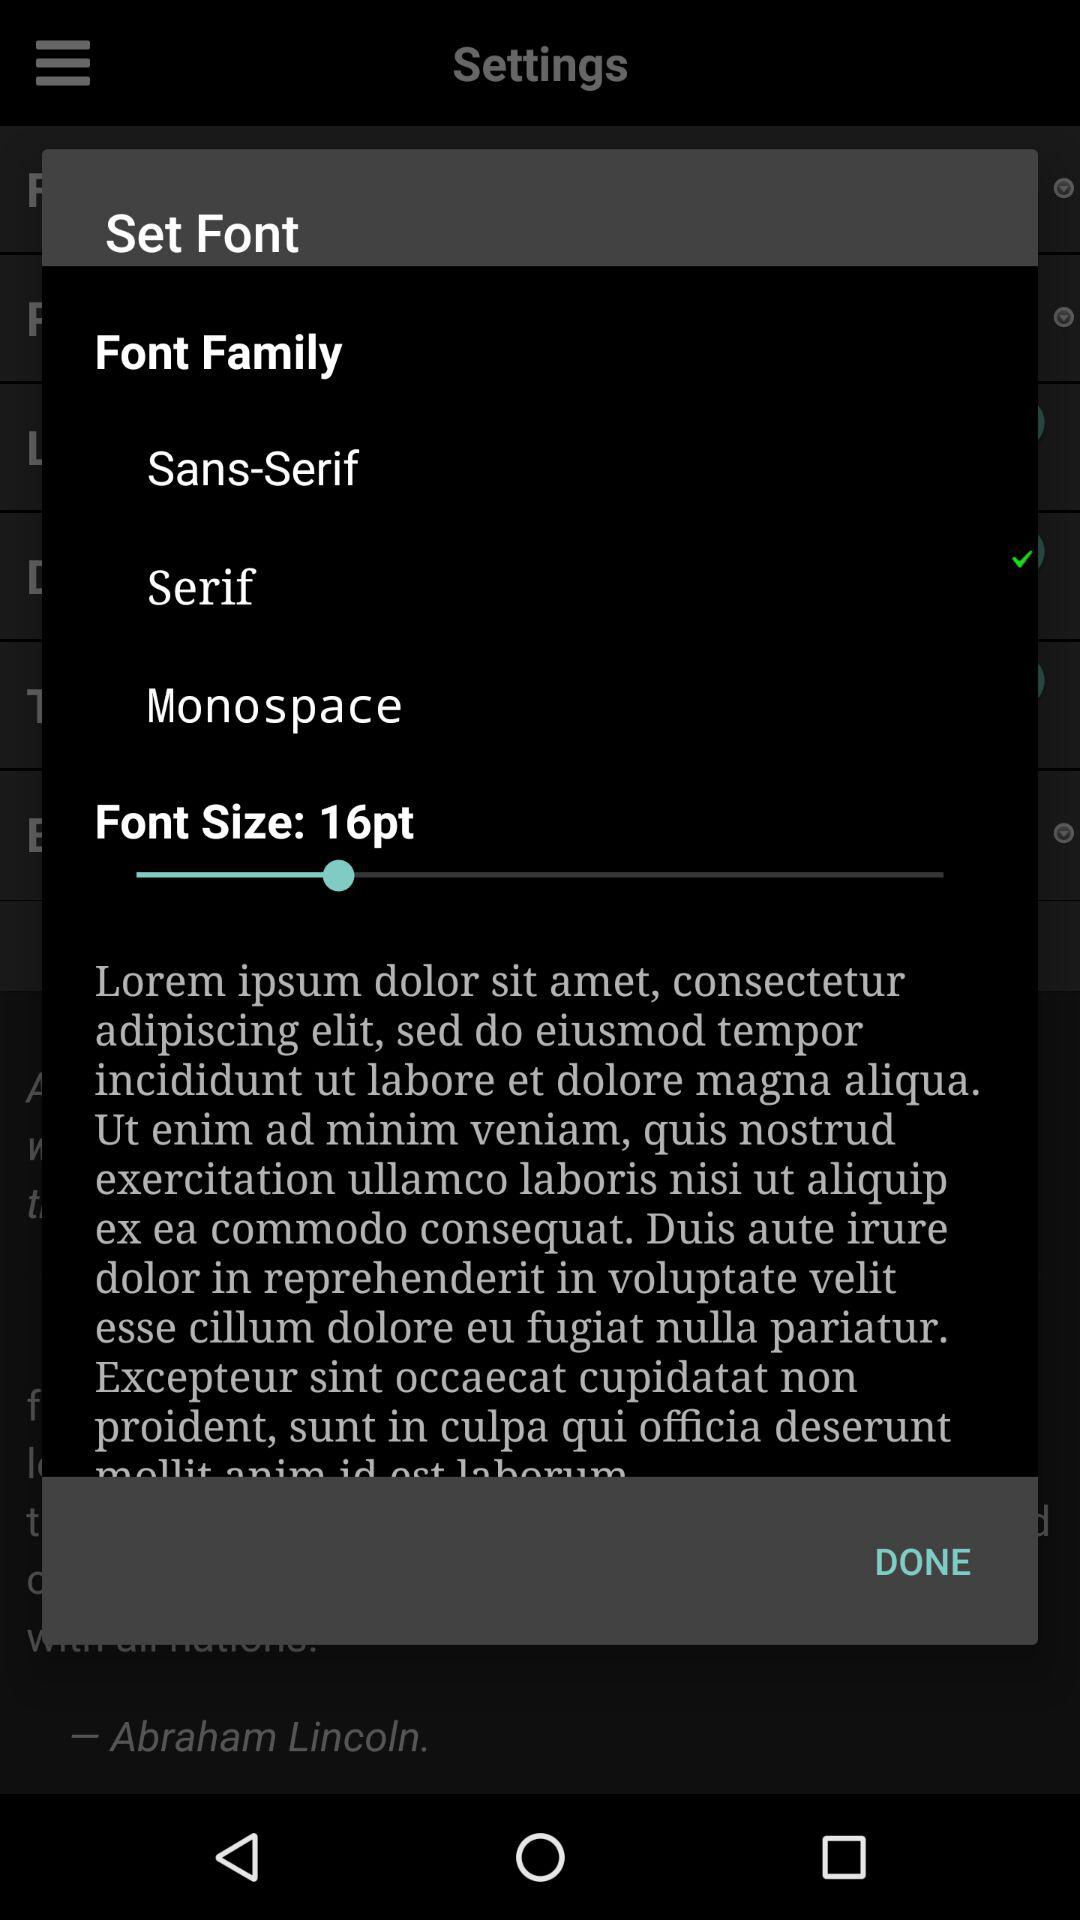What is the selected "Font Family"? The selected "Font Family" is "Serif". 